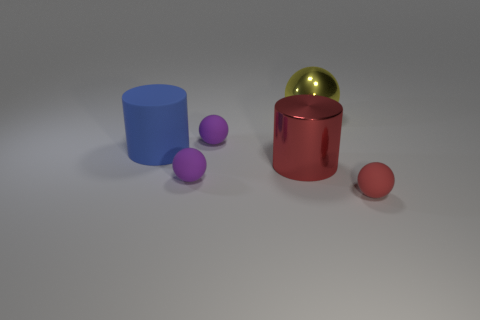Subtract all yellow spheres. How many spheres are left? 3 Subtract all blue balls. Subtract all blue blocks. How many balls are left? 4 Add 3 tiny gray metallic cylinders. How many objects exist? 9 Subtract all balls. How many objects are left? 2 Add 4 small green matte things. How many small green matte things exist? 4 Subtract 0 blue balls. How many objects are left? 6 Subtract all big cylinders. Subtract all small red things. How many objects are left? 3 Add 4 big cylinders. How many big cylinders are left? 6 